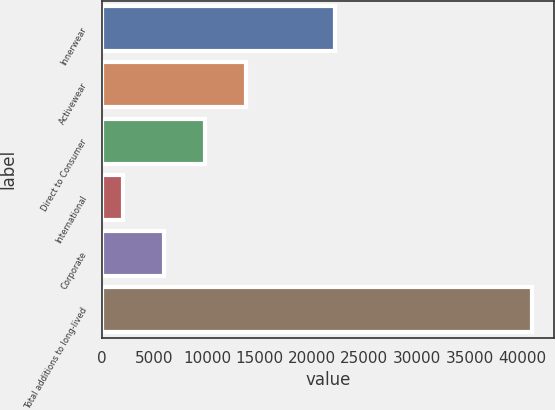<chart> <loc_0><loc_0><loc_500><loc_500><bar_chart><fcel>Innerwear<fcel>Activewear<fcel>Direct to Consumer<fcel>International<fcel>Corporate<fcel>Total additions to long-lived<nl><fcel>22241<fcel>13735.1<fcel>9841.4<fcel>2054<fcel>5947.7<fcel>40991<nl></chart> 